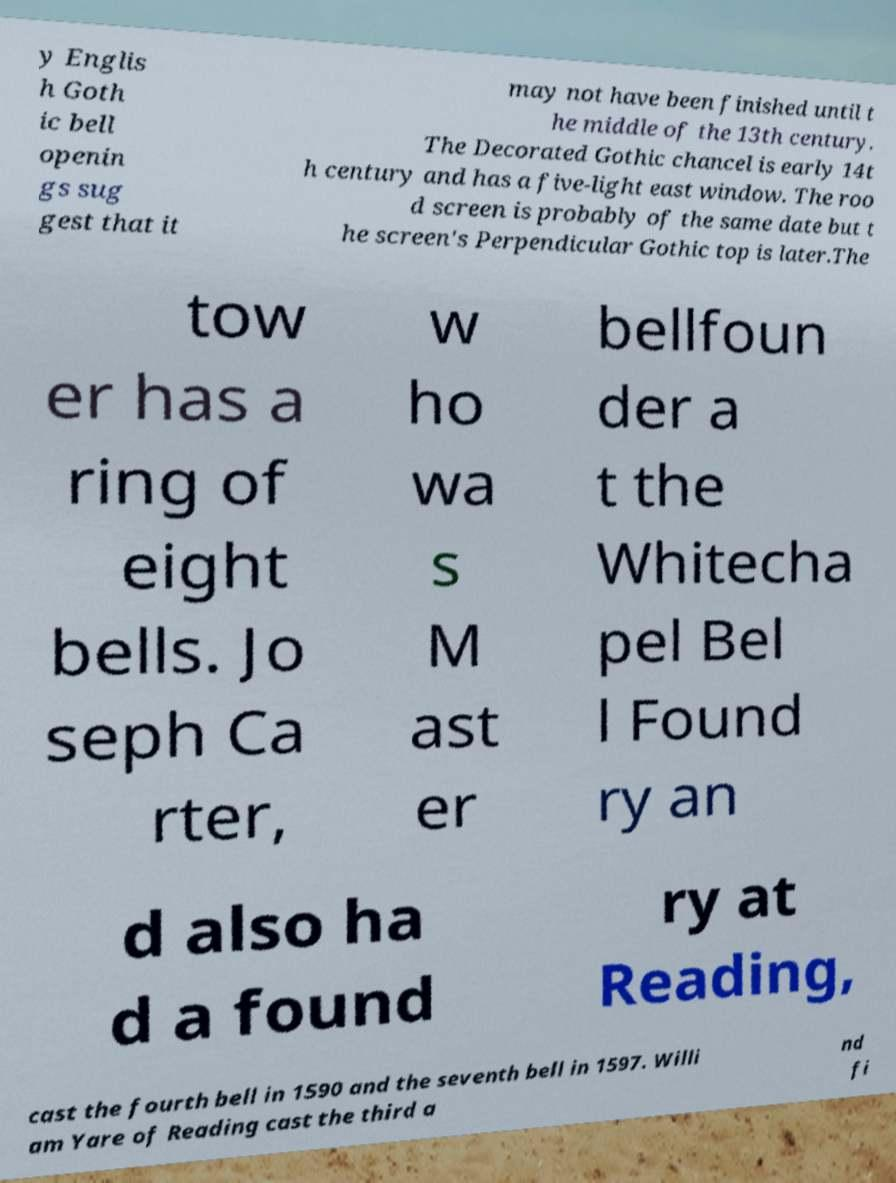Please identify and transcribe the text found in this image. y Englis h Goth ic bell openin gs sug gest that it may not have been finished until t he middle of the 13th century. The Decorated Gothic chancel is early 14t h century and has a five-light east window. The roo d screen is probably of the same date but t he screen's Perpendicular Gothic top is later.The tow er has a ring of eight bells. Jo seph Ca rter, w ho wa s M ast er bellfoun der a t the Whitecha pel Bel l Found ry an d also ha d a found ry at Reading, cast the fourth bell in 1590 and the seventh bell in 1597. Willi am Yare of Reading cast the third a nd fi 